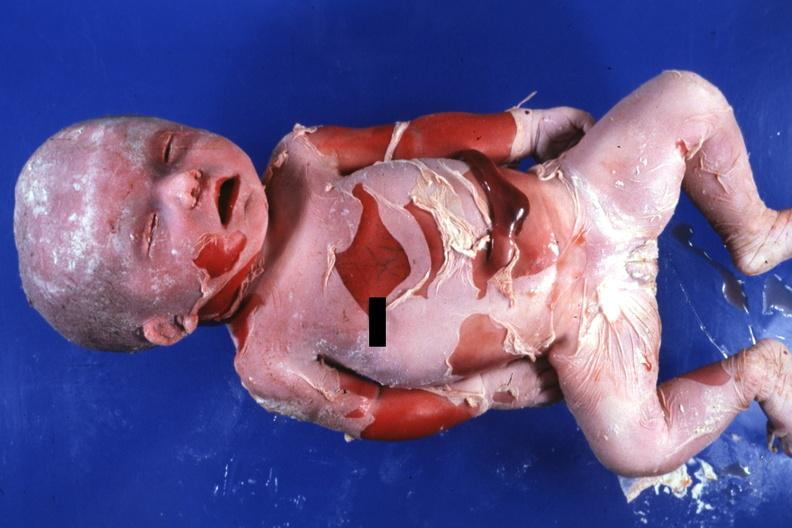how is natural color advanced?
Answer the question using a single word or phrase. Typical 